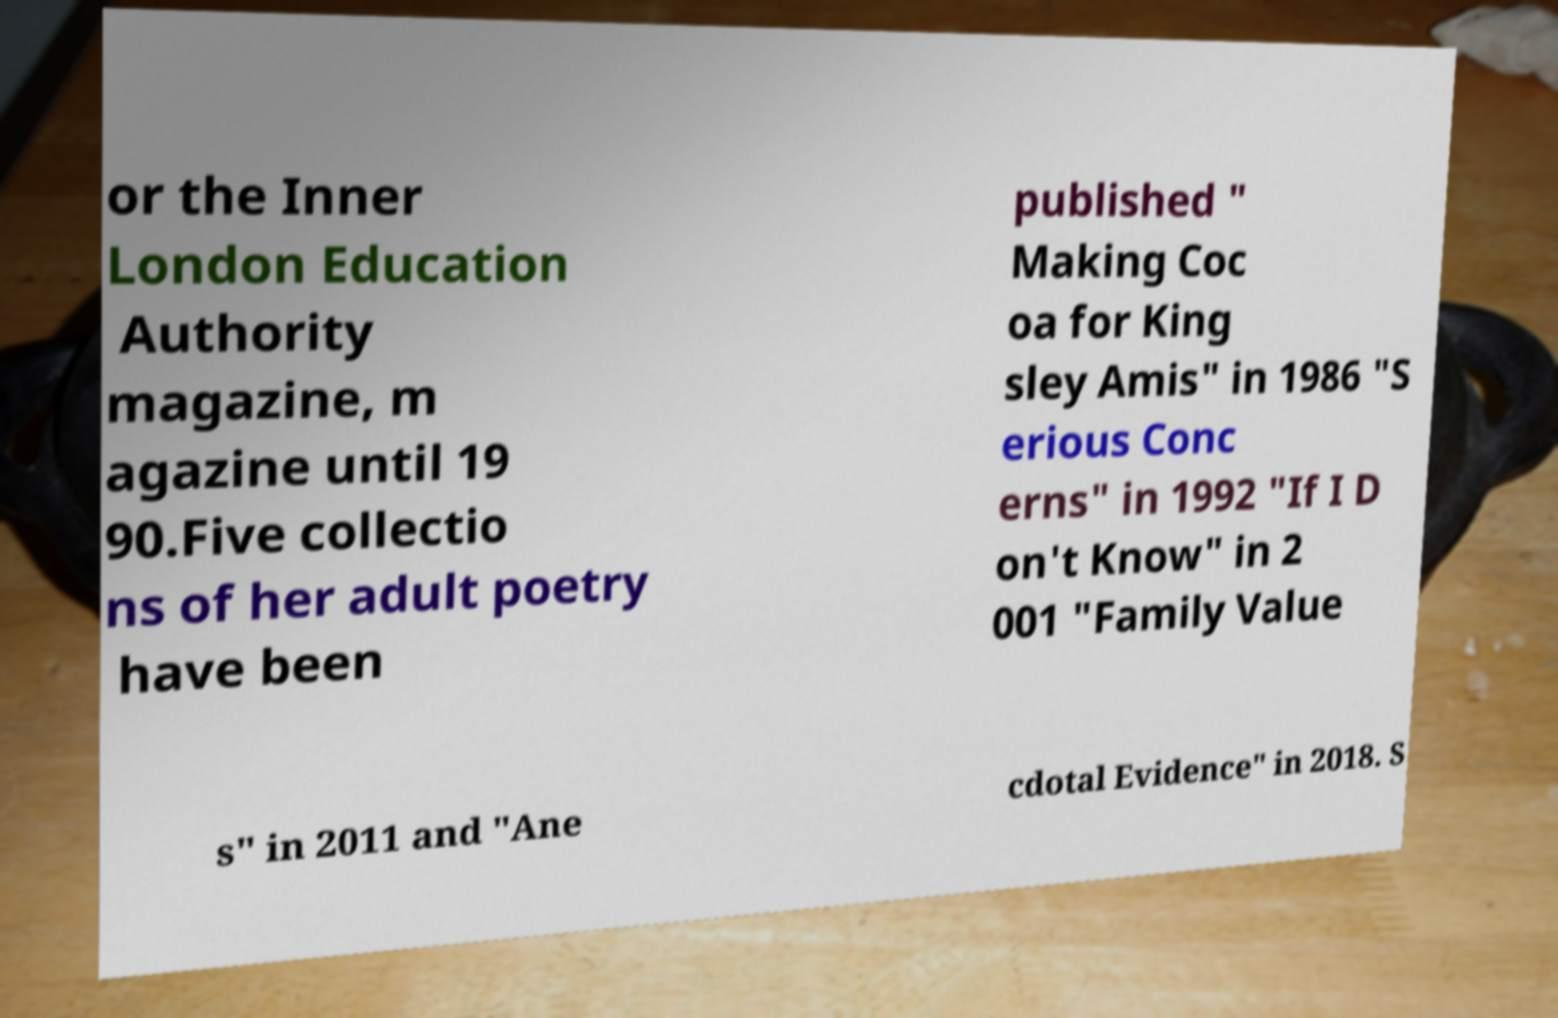Please identify and transcribe the text found in this image. or the Inner London Education Authority magazine, m agazine until 19 90.Five collectio ns of her adult poetry have been published " Making Coc oa for King sley Amis" in 1986 "S erious Conc erns" in 1992 "If I D on't Know" in 2 001 "Family Value s" in 2011 and "Ane cdotal Evidence" in 2018. S 